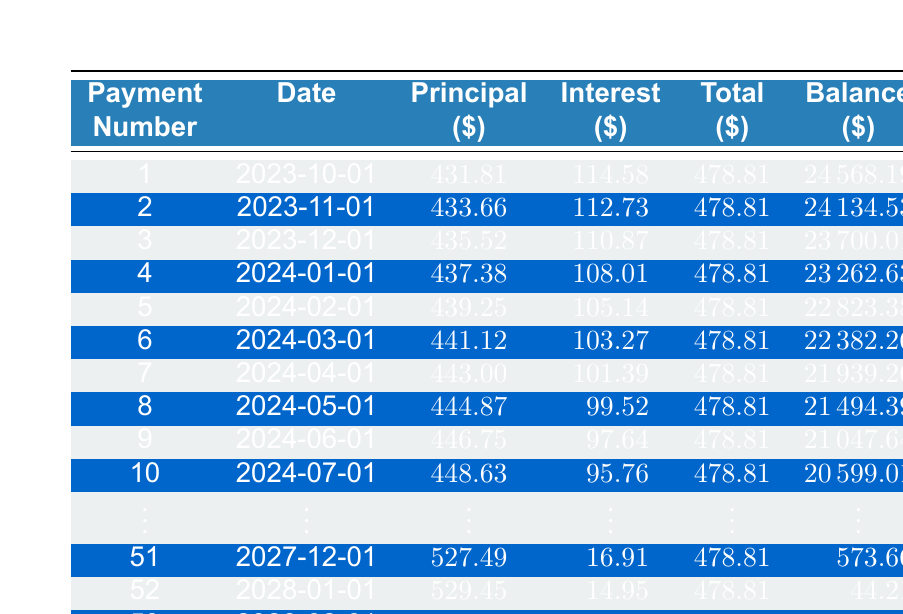What is the total loan amount for John Doe? The loan amount is directly provided in the loan details section of the table. It states the loan amount is 25000.
Answer: 25000 How much is the monthly payment for the loan? The table shows the monthly payment specified in the loan details is 478.81.
Answer: 478.81 What is the principal payment for the first payment? The first row in the amortization schedule indicates that the principal payment for the first payment is 431.81.
Answer: 431.81 What is the total amount paid in interest during the first three payments? The interest payments for the first three months are 114.58, 112.73, and 110.87. Summing these gives 114.58 + 112.73 + 110.87 = 338.18.
Answer: 338.18 Is the interest payment for the second payment less than the principal payment for the second payment? The interest payment for the second payment is 112.73, while the principal payment is 433.66. Since 112.73 is less than 433.66, the statement is true.
Answer: Yes What is the remaining balance after the 10th payment? In the amortization schedule, the remaining balance after the 10th payment is listed as 20599.01.
Answer: 20599.01 What is the total payment made by John Doe after 6 months? To find the total payment made after 6 months, we take the monthly payment of 478.81 and multiply by 6: 478.81 * 6 = 2872.86.
Answer: 2872.86 What is the difference between the principal payment of the 5th and the 4th payment? The principal payment for the 5th payment is 439.25 and for the 4th payment is 437.38. The difference is 439.25 - 437.38 = 1.87.
Answer: 1.87 How many payments are left after the 40th payment? The total loan term is 53 payments, so after the 40th payment, there are 53 - 40 = 13 payments left.
Answer: 13 